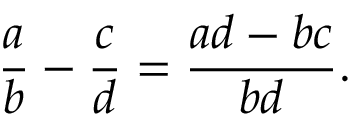Convert formula to latex. <formula><loc_0><loc_0><loc_500><loc_500>{ \frac { a } { b } } - { \frac { c } { d } } = { \frac { a d - b c } { b d } } .</formula> 